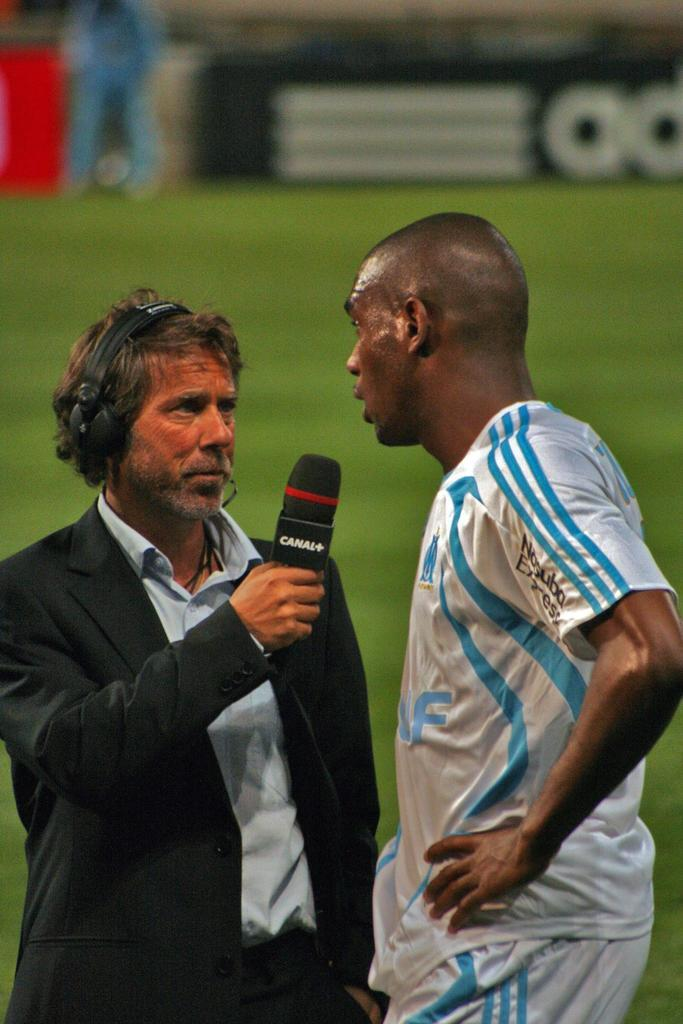How many people are in the image? There are two persons standing in the image. What is the person wearing a black jacket holding? The person in the black jacket is holding a microphone. What color is the grass in the image? The grass in the image is green in color. What type of sign is present in the image? There is an advertisement board in the image. Can you see a pickle on the ground near the persons in the image? There is no pickle present in the image. Is there a snake slithering through the grass in the image? There is no snake visible in the image. 